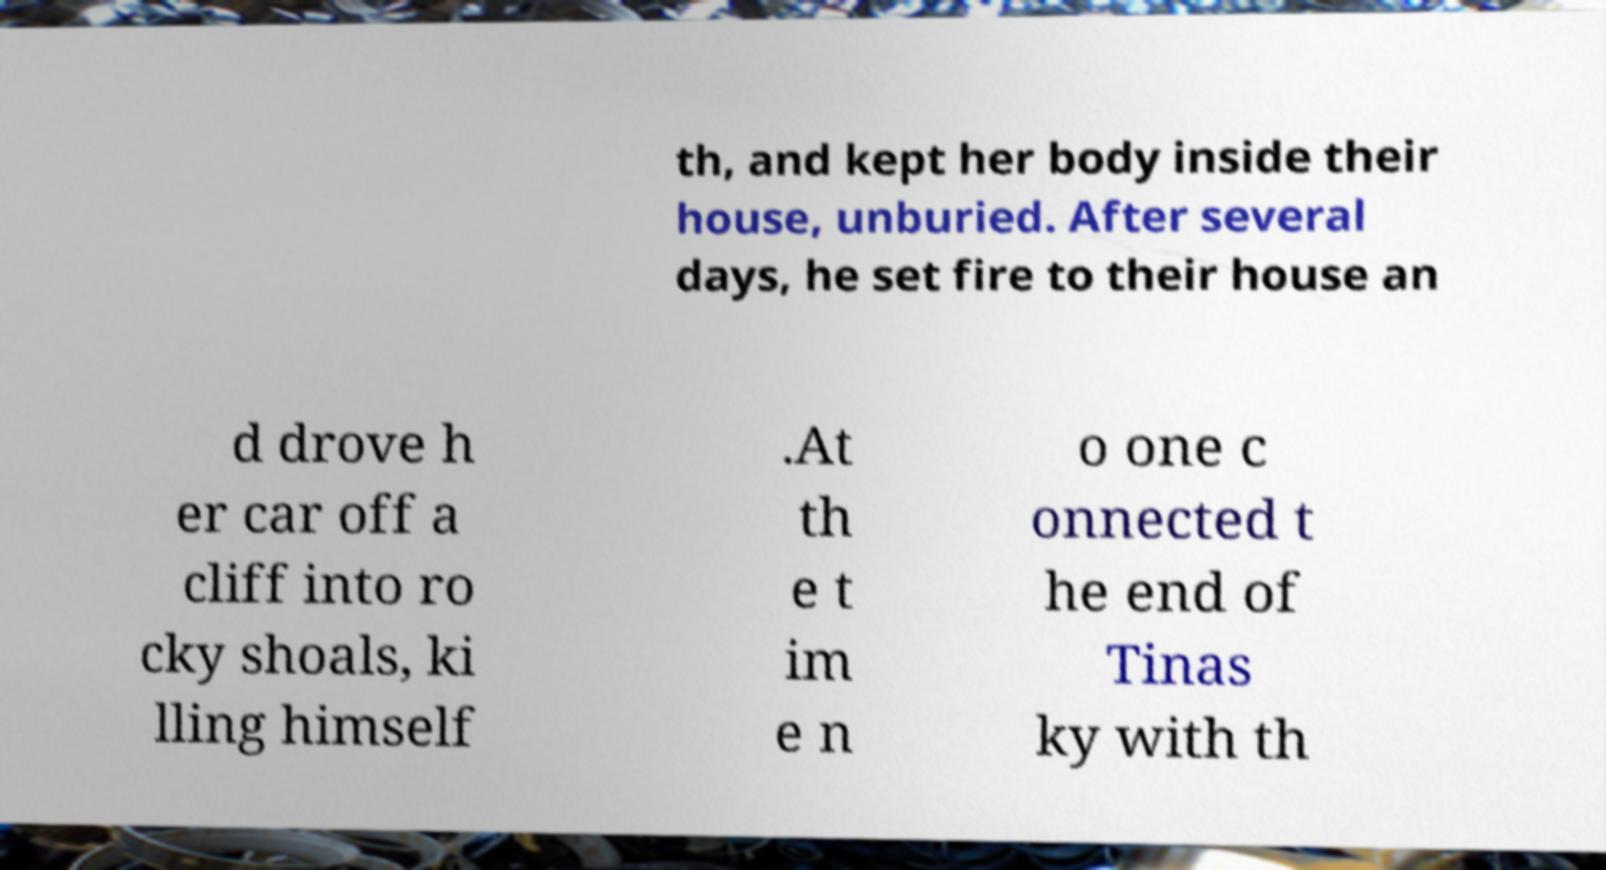Could you extract and type out the text from this image? th, and kept her body inside their house, unburied. After several days, he set fire to their house an d drove h er car off a cliff into ro cky shoals, ki lling himself .At th e t im e n o one c onnected t he end of Tinas ky with th 